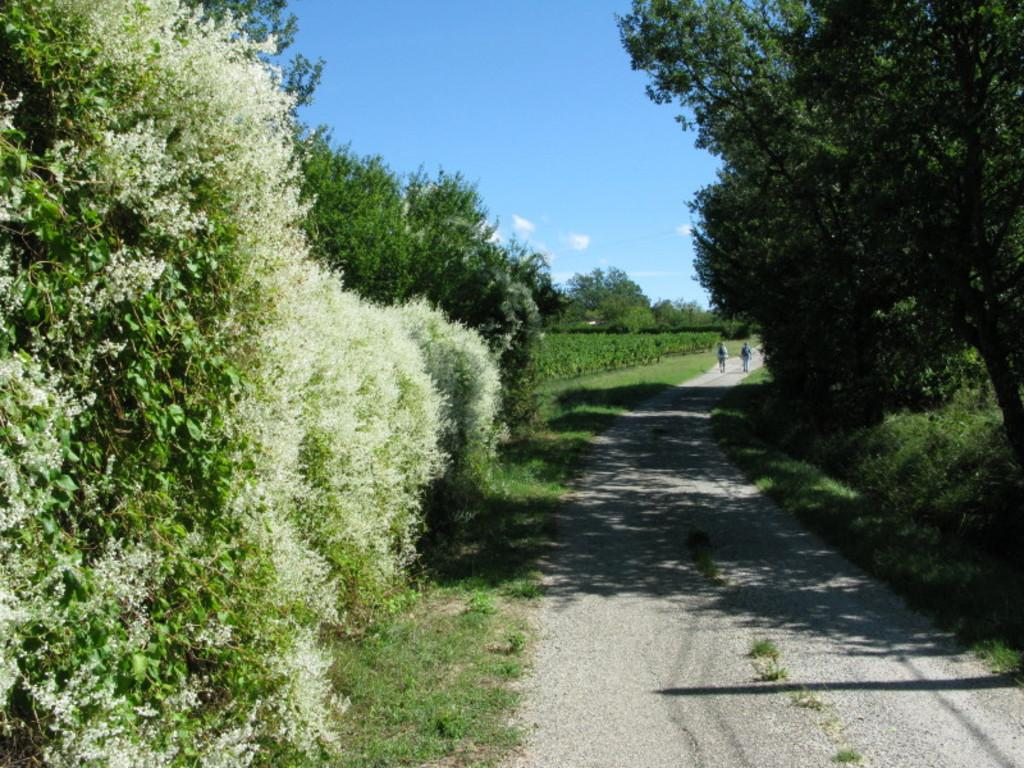What are the two persons in the image doing? The two persons in the image are walking. What can be seen in the background of the image? There are trees and the sky visible in the background of the image. What is the color of the trees in the image? The trees in the image are green in color. What is the color of the sky in the image? The sky in the image is blue and white in color. What type of waste can be seen on the wall in the image? There is no wall or waste present in the image; it features two persons walking with trees and the sky in the background. 